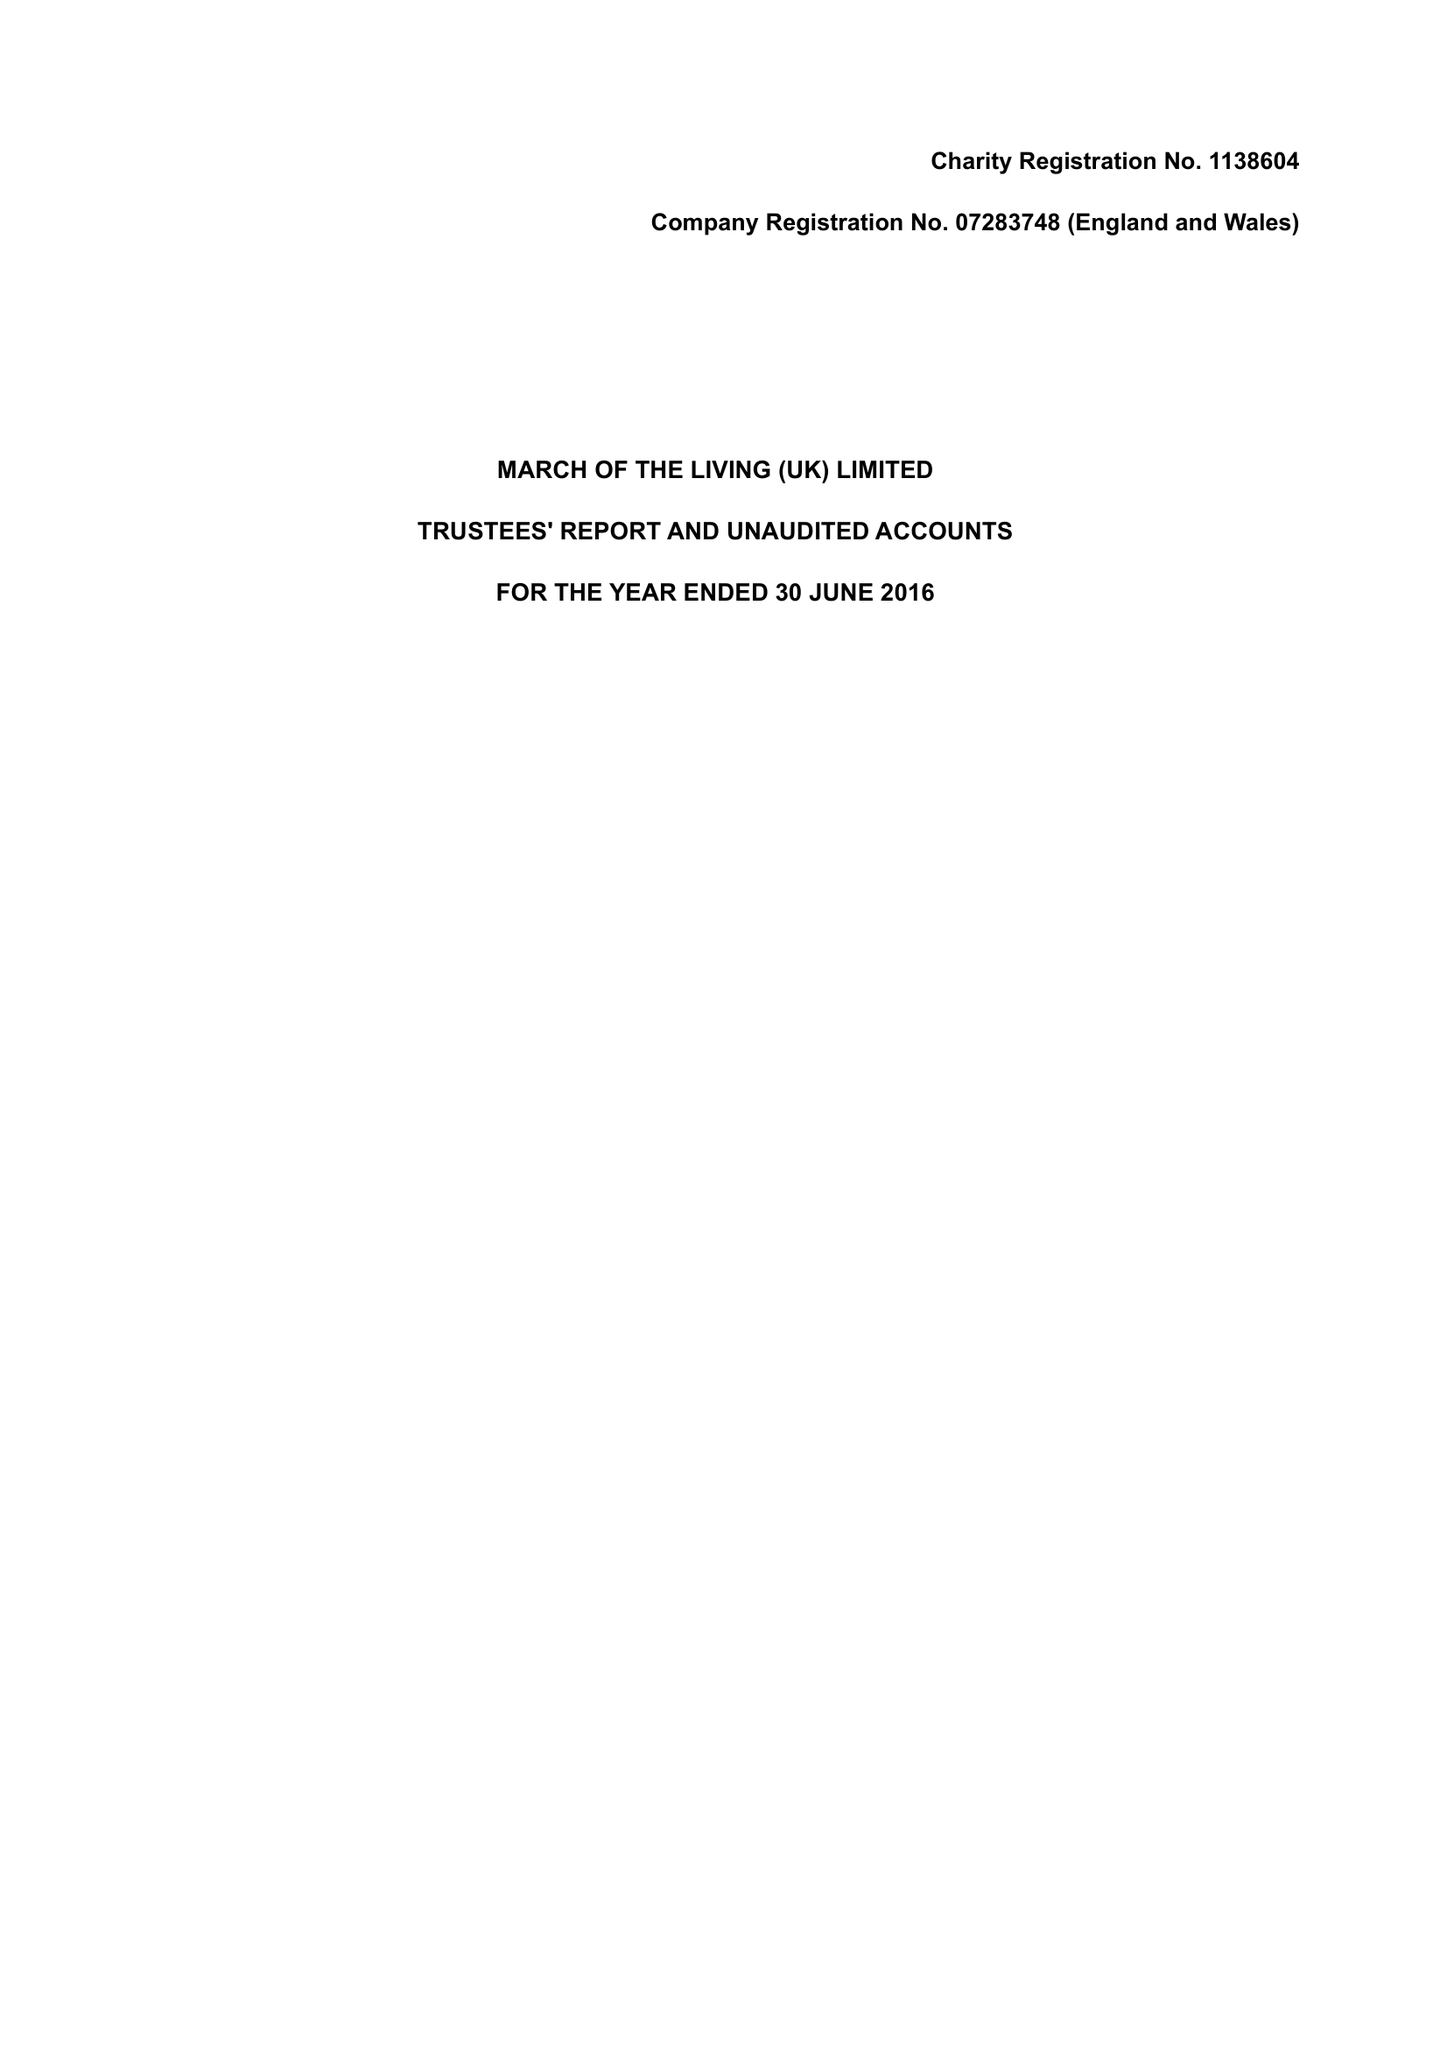What is the value for the charity_number?
Answer the question using a single word or phrase. 1138604 